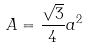<formula> <loc_0><loc_0><loc_500><loc_500>A = \frac { \sqrt { 3 } } { 4 } a ^ { 2 }</formula> 